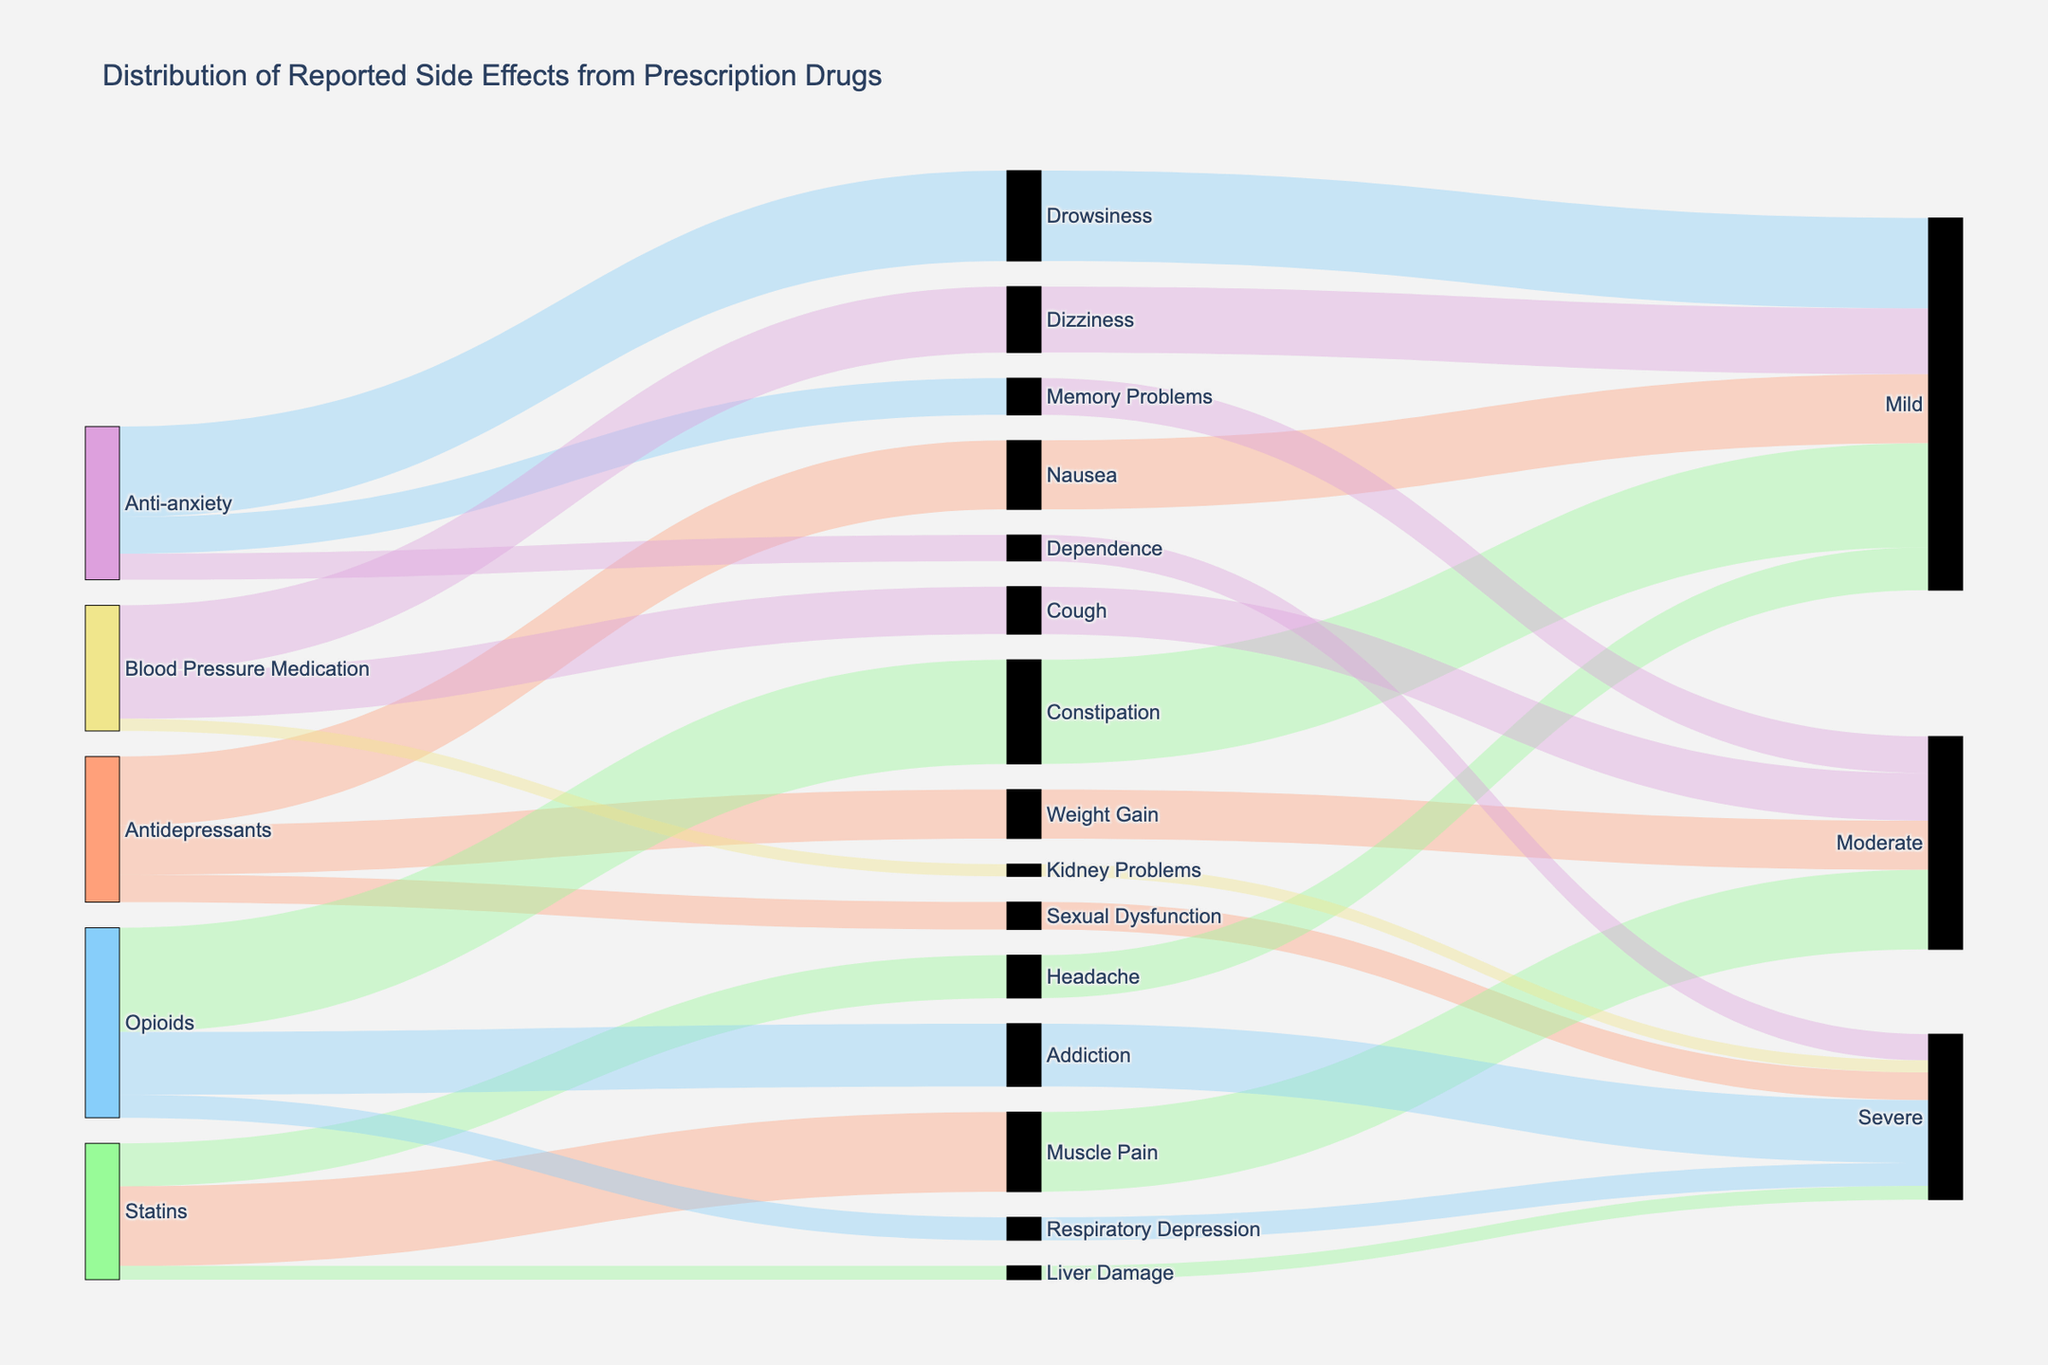What is the most commonly reported side effect for antidepressants? Look for the largest value linked to side effects from antidepressants. Nausea has a count of 450, which is the highest among side effects for antidepressants.
Answer: Nausea Which prescription drug type has the highest reported cases of severe side effects in total? Sum the counts of severe side effects for each drug type. Antidepressants: 180, Statins: 90, Opioids: 410 + 150 = 560, Anti-anxiety: 170, Blood Pressure Medication: 80. Opioids have the highest total.
Answer: Opioids Is Muscle Pain more frequently reported as a side effect of Statins or Drowsiness as a side effect of Anti-anxiety drugs? Compare the number of reports for Muscle Pain from Statins (520) and Drowsiness from Anti-anxiety drugs (590). Drowsiness has a higher count.
Answer: Drowsiness What percentage of side effects from opioids are reported as moderate? Opioids have no moderate side effects reported. There are only mild and severe ones (Constipation, Addiction, Respiratory Depression). Therefore, the percentage is 0%.
Answer: 0% For Blood Pressure Medications, which side effect has the second highest count? Identify the counts for all side effects of Blood Pressure Medications: Dizziness (430), Cough (310), Kidney Problems (80). Cough has the second highest count.
Answer: Cough How many total reported cases of mild side effects are there across all drug types? Add up all cases of mild side effects: Nausea (450), Headache (280), Constipation (680), Drowsiness (590), Dizziness (430). The total sum is 2430.
Answer: 2430 Which combination of drug type and side effect has the highest reporting count? Examine all combinations and their counts: Antidepressants and Nausea (450), Antidepressants and Weight Gain (320), Antidepressants and Sexual Dysfunction (180), Statins and Muscle Pain (520), Statins and Liver Damage (90), Statins and Headache (280), Opioids and Constipation (680), Opioids and Addiction (410), Opioids and Respiratory Depression (150), Anti-anxiety and Drowsiness (590), Anti-anxiety and Memory Problems (240), Anti-anxiety and Dependence (170), Blood Pressure Medication and Dizziness (430), Blood Pressure Medication and Cough (310), Blood Pressure Medication and Kidney Problems (80). The highest count is Opioids and Constipation (680).
Answer: Opioids and Constipation Which severity level has the highest combined total cases across all side effects? Add up the counts for each severity level: Mild: 450 + 280 + 680 + 590 + 430 = 2430, Moderate: 320 + 520 + 240 + 310 = 1390, Severe: 180 + 90 + 410 + 150 + 170 + 80 = 1090. Mild has the highest combined total cases.
Answer: Mild 